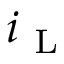<formula> <loc_0><loc_0><loc_500><loc_500>i _ { L }</formula> 